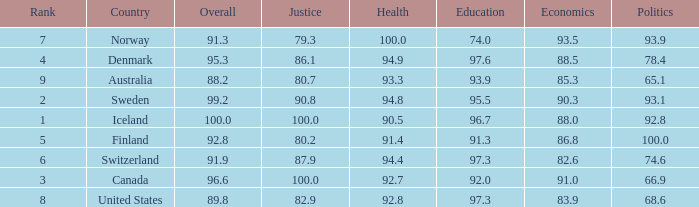What's the economics score with justice being 90.8 90.3. 